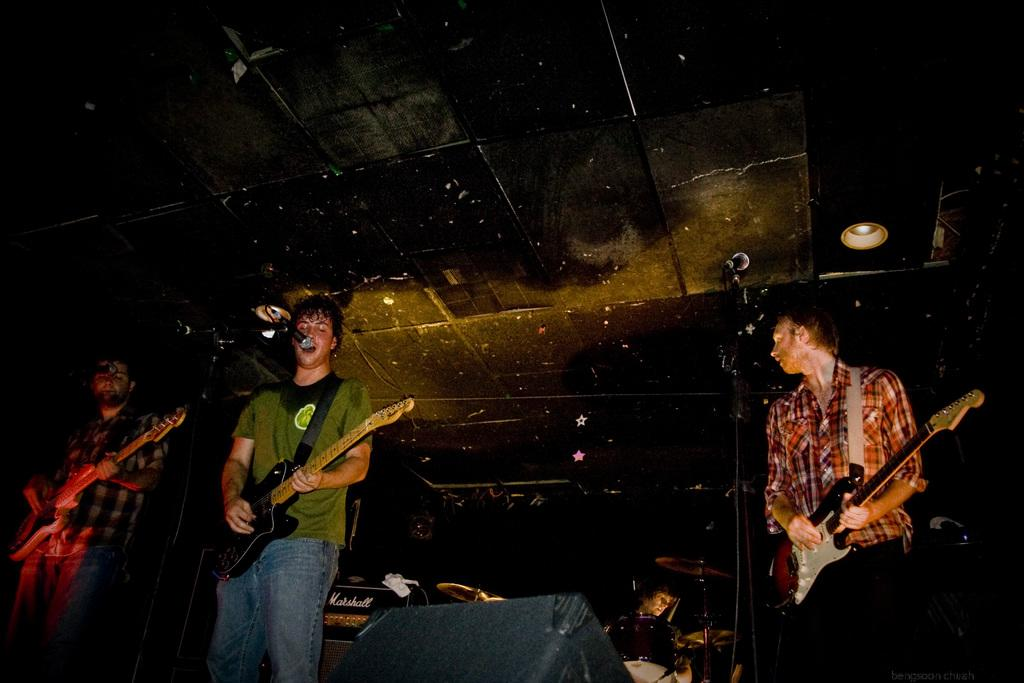How many people are in the image? A: There are three persons in the image. What are the persons doing in the image? The persons are standing and holding guitars. What object is present in the image that is commonly used for amplifying sound? There is a microphone in the image. What type of light is visible in the image? There is a light in the image. What can be inferred about the scene in the image? The image depicts a musical band. What type of turkey is being served on a plate in the image? There is no turkey or plate present in the image; it depicts a musical band. What country is the band from in the image? The image does not provide any information about the country of origin of the band. 